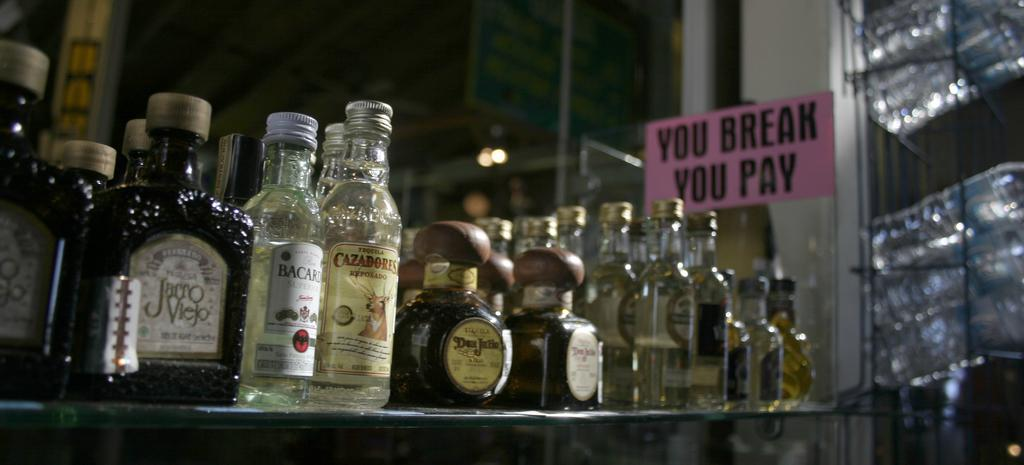<image>
Offer a succinct explanation of the picture presented. Many bottles of liqueur sit on a counter next to a sign that says "you break you pay." 